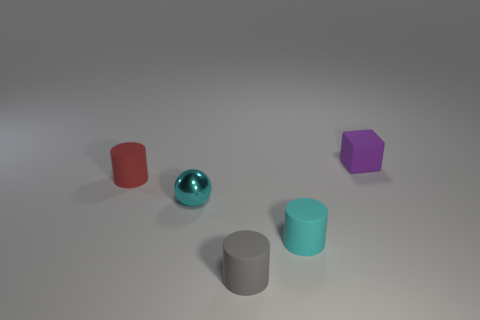Add 1 metal spheres. How many objects exist? 6 Subtract all blocks. How many objects are left? 4 Add 2 tiny red rubber cylinders. How many tiny red rubber cylinders are left? 3 Add 2 small cyan matte things. How many small cyan matte things exist? 3 Subtract 0 brown spheres. How many objects are left? 5 Subtract all blue metal things. Subtract all purple cubes. How many objects are left? 4 